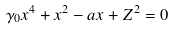<formula> <loc_0><loc_0><loc_500><loc_500>\gamma _ { 0 } x ^ { 4 } + x ^ { 2 } - a x + Z ^ { 2 } = 0</formula> 